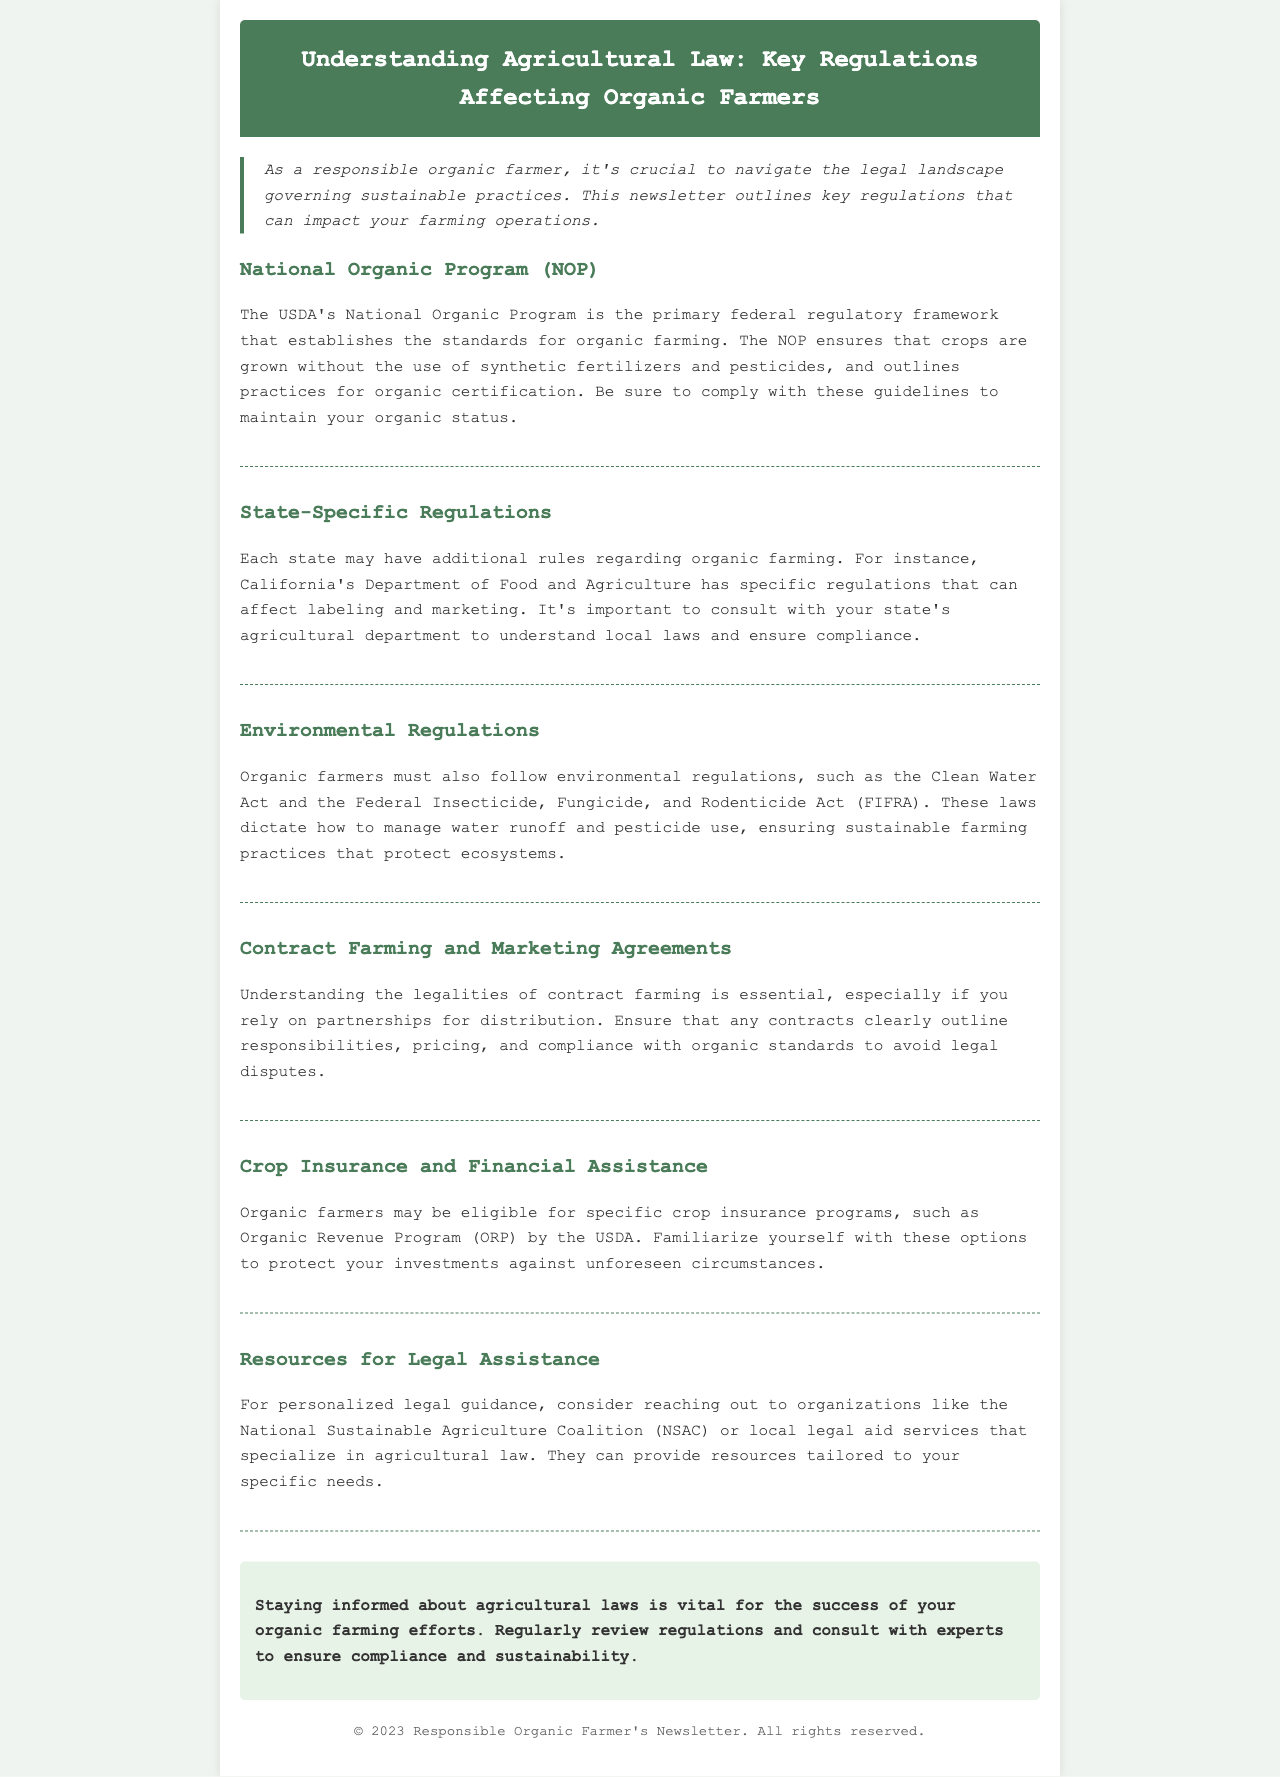What is the main federal regulatory framework for organic farming? The document states that the USDA's National Organic Program (NOP) is the primary federal regulatory framework for organic farming.
Answer: National Organic Program (NOP) Which department establishes regulations specific to organic farming in California? The document refers to California's Department of Food and Agriculture as the entity that establishes specific regulations for organic farming.
Answer: California's Department of Food and Agriculture What is the purpose of the Clean Water Act mentioned in the document? The Clean Water Act dictates how to manage water runoff, ensuring sustainable farming practices that protect ecosystems.
Answer: Manage water runoff What program may organic farmers be eligible for regarding crop insurance? The document indicates that the USDA has a specific program called the Organic Revenue Program (ORP) that organic farmers may be eligible for.
Answer: Organic Revenue Program (ORP) What organization can provide personalized legal guidance for organic farmers? The document suggests reaching out to the National Sustainable Agriculture Coalition (NSAC) for personalized legal guidance.
Answer: National Sustainable Agriculture Coalition (NSAC) Why is understanding contract farming important for organic farmers? The document states that understanding contract farming is essential to ensure that contracts clearly outline responsibilities and compliance with organic standards.
Answer: Avoid legal disputes What type of regulations must organic farmers adhere to under environmental laws? The document mentions that organic farmers must follow environmental regulations including the Clean Water Act and FIFRA.
Answer: Clean Water Act and FIFRA How often should organic farmers review regulations according to the document? The conclusion section emphasizes the importance of regularly reviewing regulations to ensure compliance and sustainability.
Answer: Regularly 